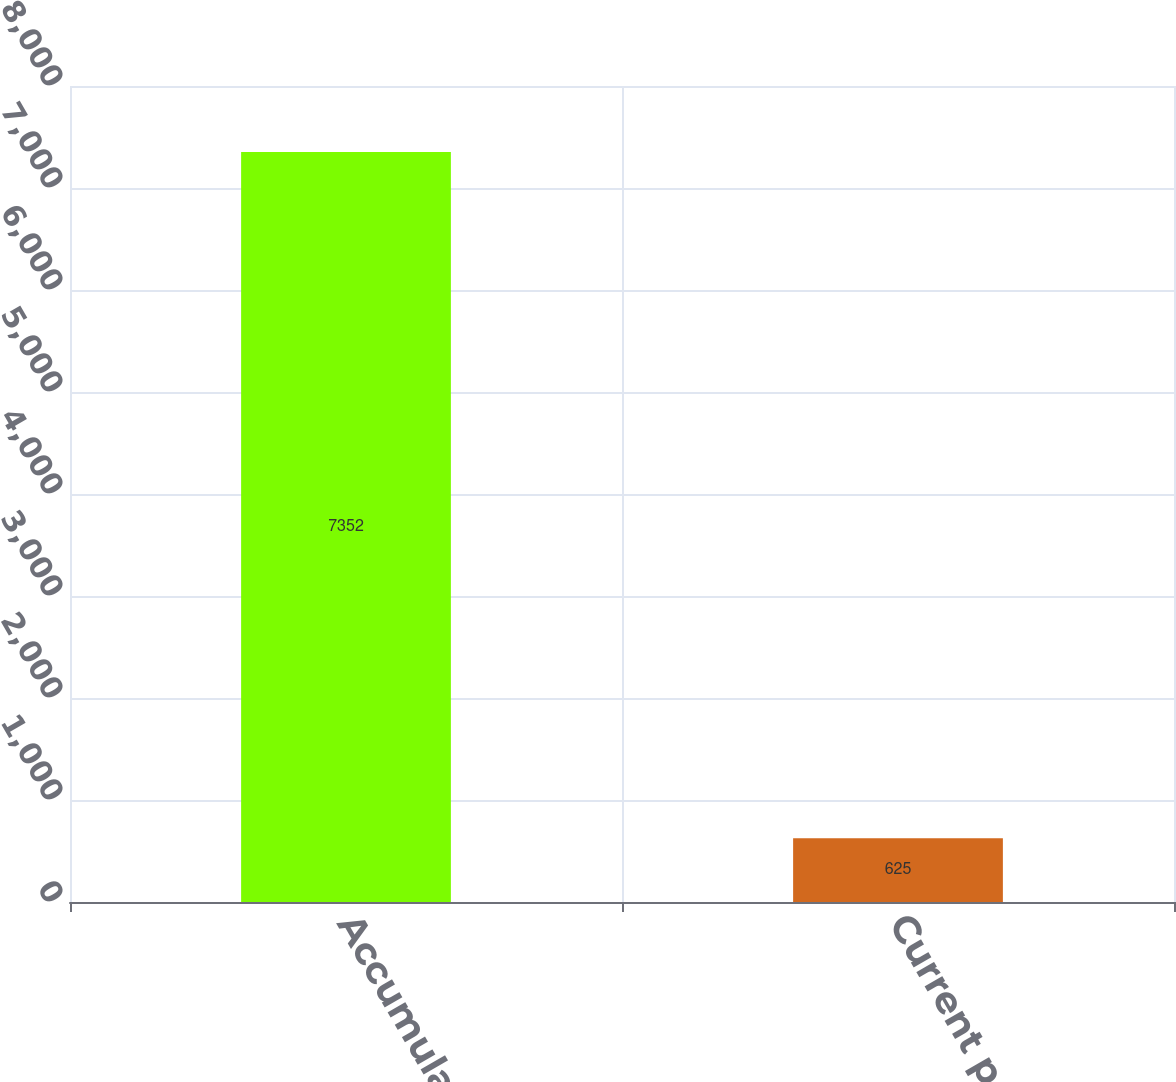Convert chart to OTSL. <chart><loc_0><loc_0><loc_500><loc_500><bar_chart><fcel>Accumulated other<fcel>Current period other<nl><fcel>7352<fcel>625<nl></chart> 